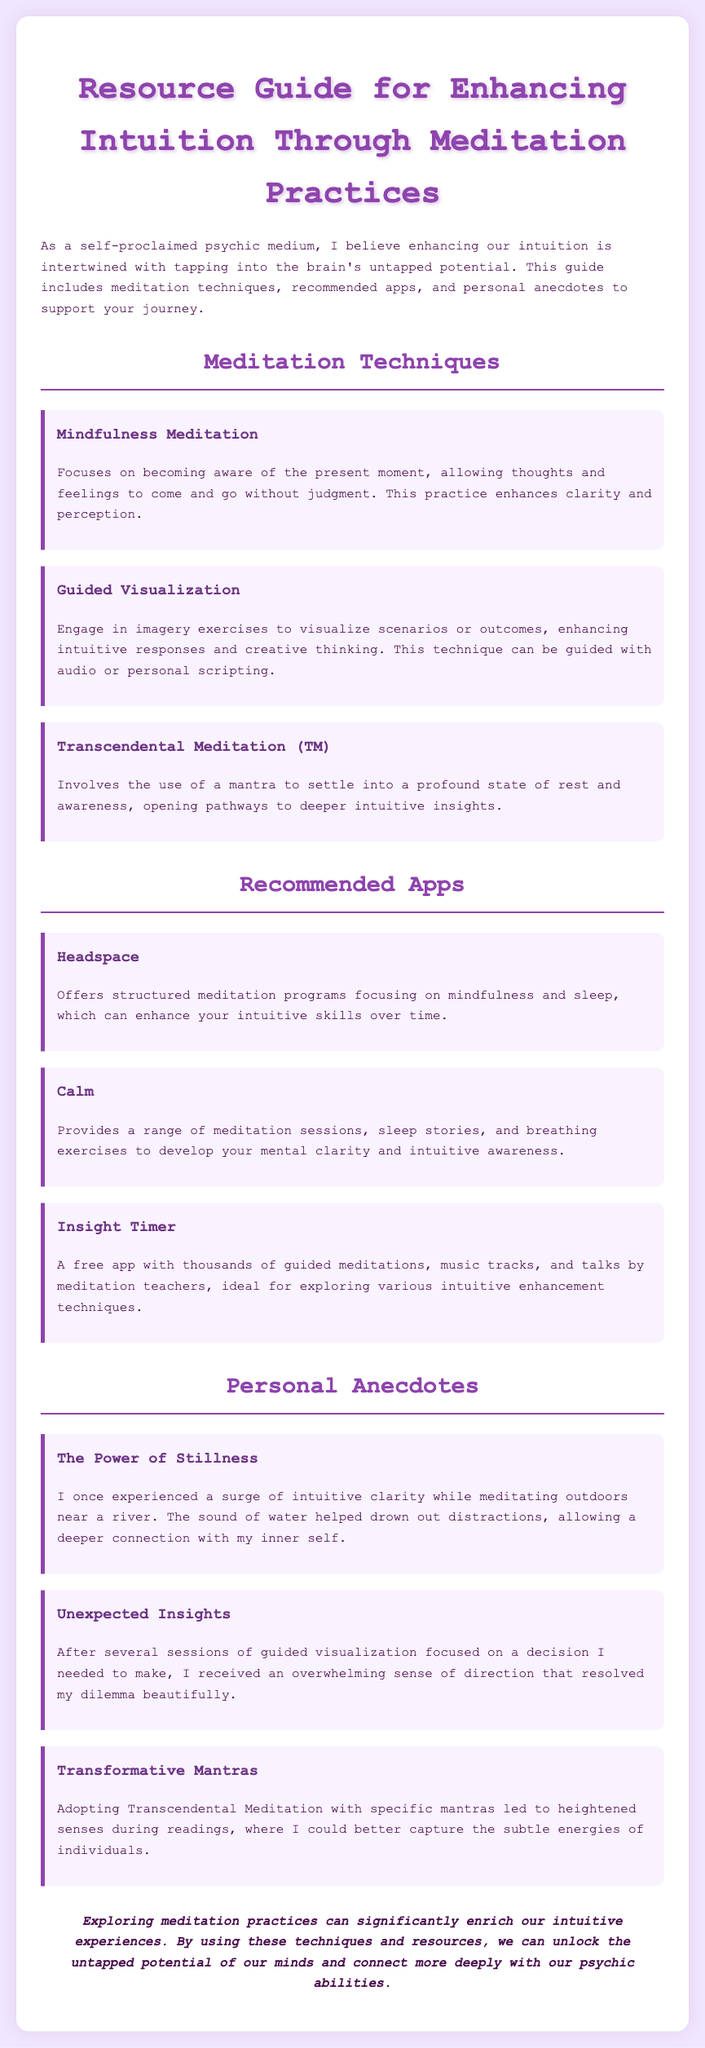What is the title of the document? The title is presented in the header of the document; it is specifically stated in the HTML.
Answer: Resource Guide for Enhancing Intuition Through Meditation Practices What meditation technique involves a mantra? This question requires connecting the technique with its description in the document.
Answer: Transcendental Meditation (TM) Which app offers structured meditation programs? The document lists different apps along with their descriptions; “structured meditation programs” is specified for one.
Answer: Headspace How many personal anecdotes are included in the document? The document contains a section on personal anecdotes where multiple stories are shared, and counting them gives the answer.
Answer: Three What is the primary focus of mindfulness meditation? This answer can be derived from the description of the technique in the document.
Answer: Present moment awareness What meditation app is free and contains thousands of resources? The answer can be found under the app section where it is mentioned specifically as free with extensive offerings.
Answer: Insight Timer Which technique involves imagery exercises? This question connects the technique with its description from the techniques listed in the document.
Answer: Guided Visualization Where did I experience a surge of intuitive clarity? The personal anecdote provides a specific location for enhanced intuition during meditation.
Answer: Near a river 